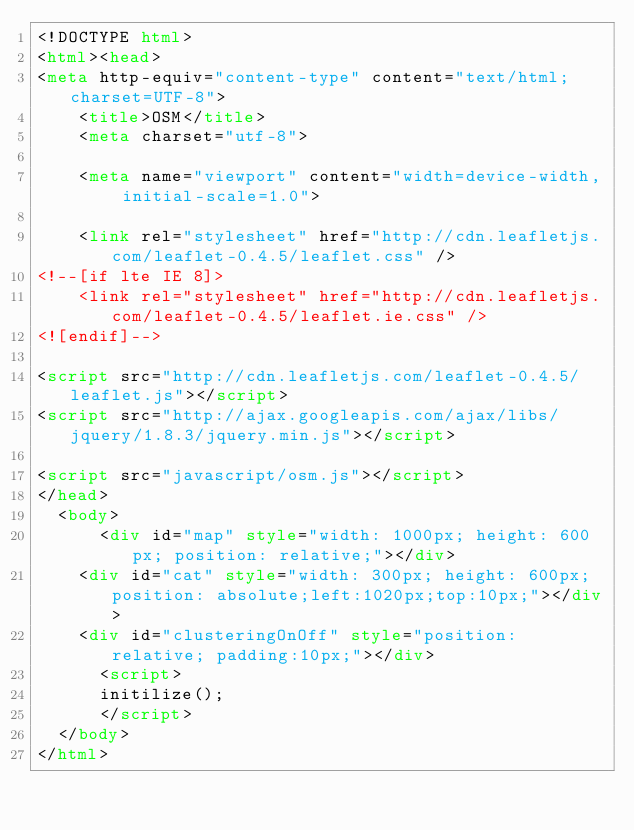<code> <loc_0><loc_0><loc_500><loc_500><_HTML_><!DOCTYPE html>
<html><head>
<meta http-equiv="content-type" content="text/html; charset=UTF-8">
	<title>OSM</title>
	<meta charset="utf-8">

	<meta name="viewport" content="width=device-width, initial-scale=1.0">

	<link rel="stylesheet" href="http://cdn.leafletjs.com/leaflet-0.4.5/leaflet.css" />
<!--[if lte IE 8]>
    <link rel="stylesheet" href="http://cdn.leafletjs.com/leaflet-0.4.5/leaflet.ie.css" />
<![endif]-->

<script src="http://cdn.leafletjs.com/leaflet-0.4.5/leaflet.js"></script>
<script src="http://ajax.googleapis.com/ajax/libs/jquery/1.8.3/jquery.min.js"></script>

<script src="javascript/osm.js"></script>
</head>
  <body>
	  <div id="map" style="width: 1000px; height: 600px; position: relative;"></div>
    <div id="cat" style="width: 300px; height: 600px; position: absolute;left:1020px;top:10px;"></div>
    <div id="clusteringOnOff" style="position: relative; padding:10px;"></div>
	  <script>
      initilize();
	  </script>
  </body>
</html>
</code> 